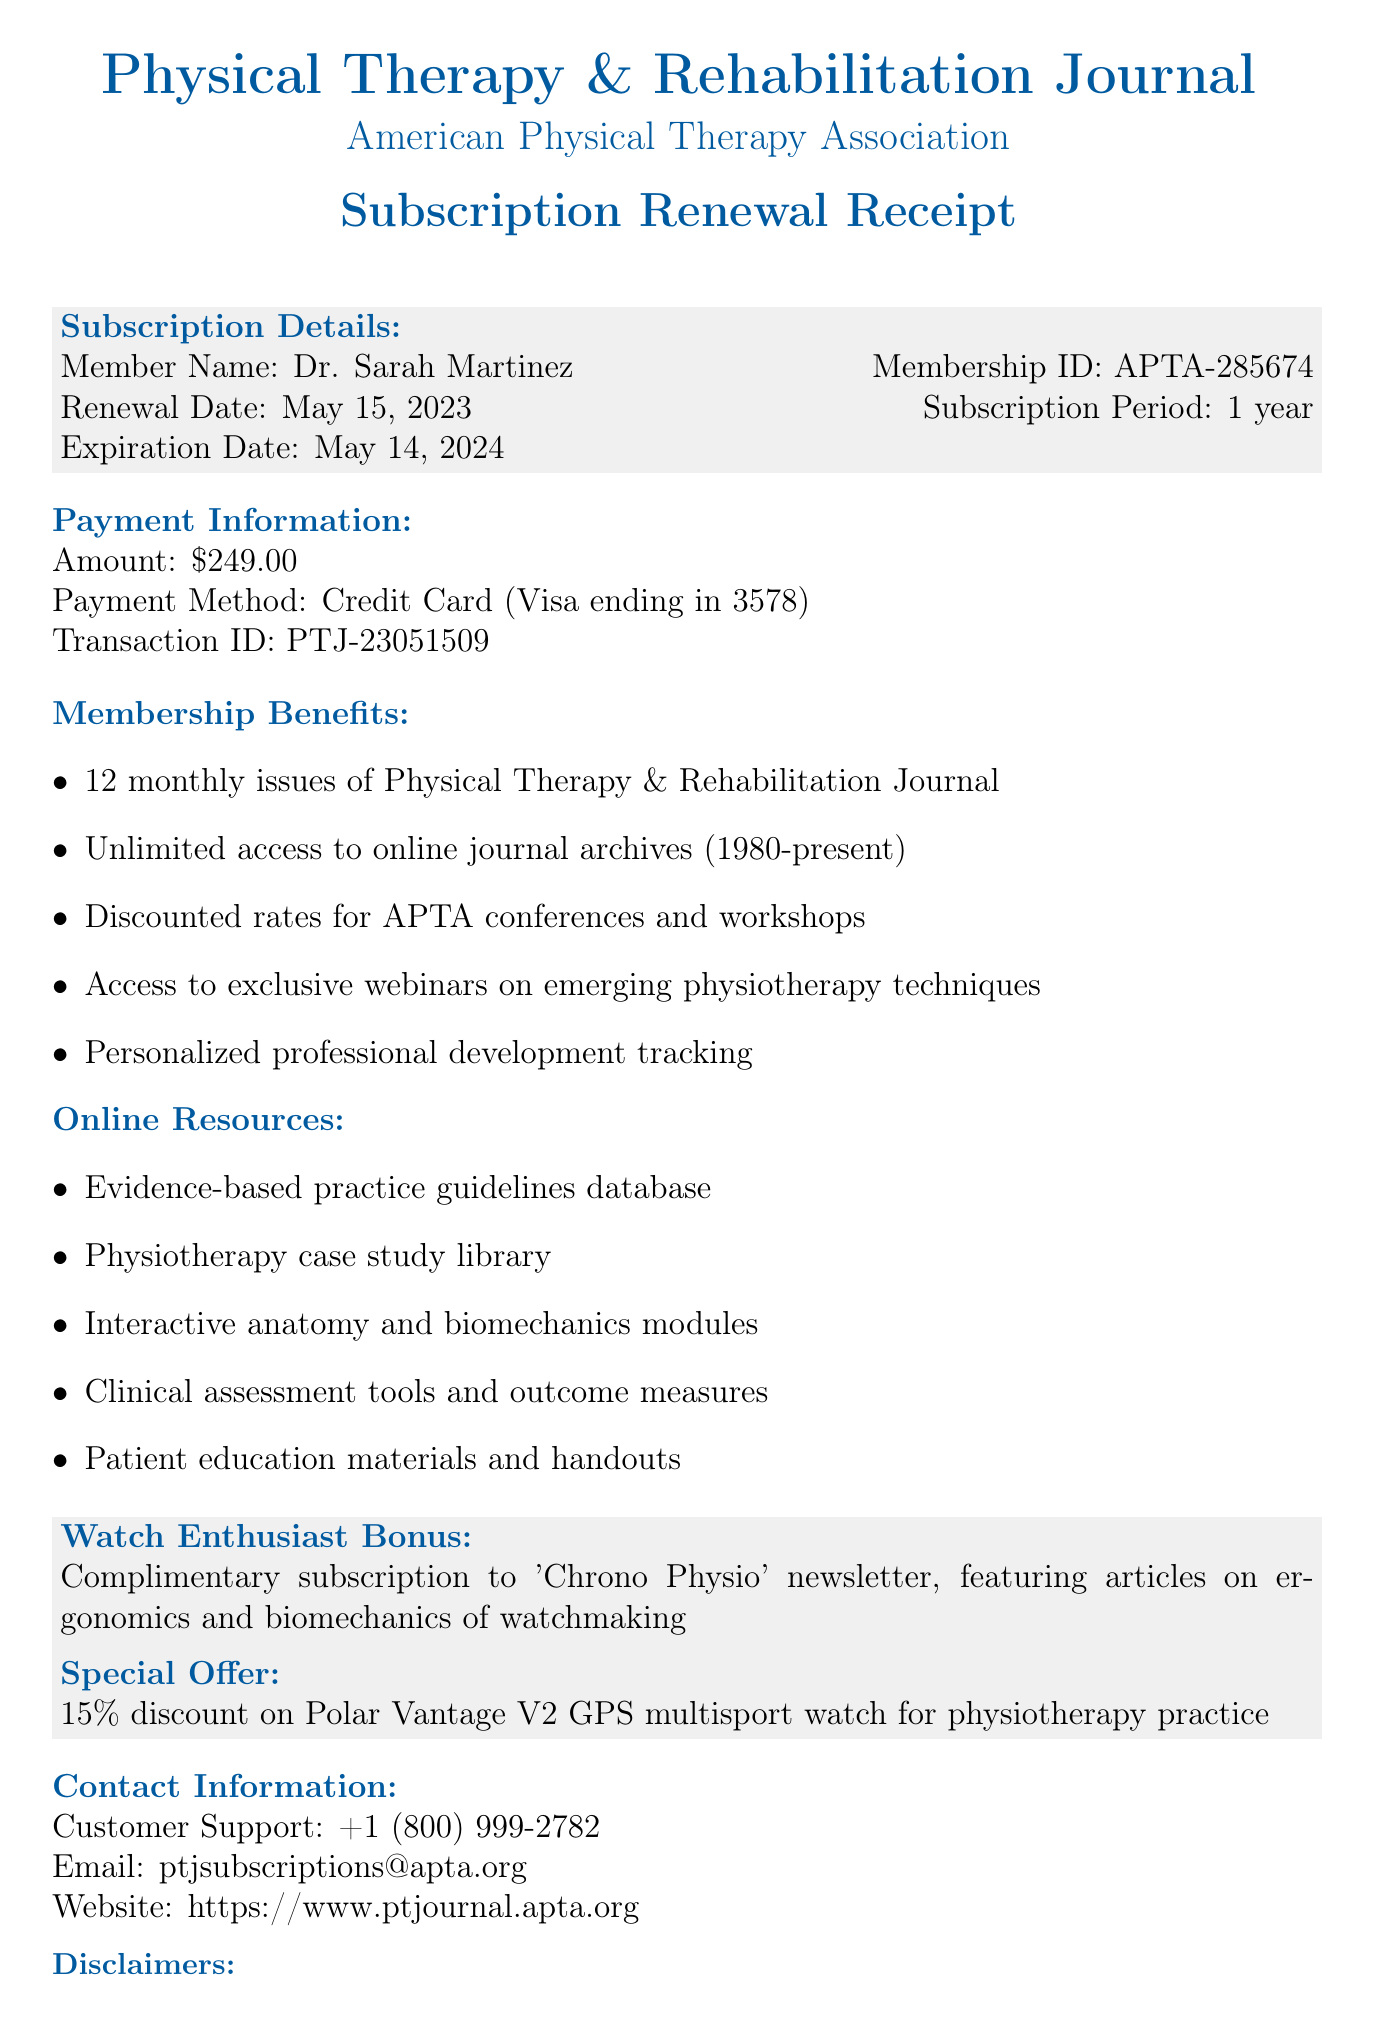What is the journal name? The journal name is provided at the top of the document as the title for the subscription renewal receipt.
Answer: Physical Therapy & Rehabilitation Journal Who is the member listed in the subscription details? The member's name is explicitly mentioned in the subscription details section of the document.
Answer: Dr. Sarah Martinez What is the renewal date? The renewal date is stated in the subscription details, indicating when the subscription was renewed.
Answer: May 15, 2023 How long is the subscription period? The subscription period is specified in the subscription details, indicating the duration of the subscription.
Answer: 1 year What payment method was used for the transaction? The payment method is described in the payment information section of the document.
Answer: Credit Card (Visa ending in 3578) How many monthly issues are included in the membership benefits? The number of monthly issues is listed specifically as part of the membership benefits in the document.
Answer: 12 What type of discount is offered for the Polar Vantage V2 watch? The discount type is detailed in the additional perks section related to the watch enthusiast bonus.
Answer: 15% discount What is the contact email for customer support? The contact email is provided in the contact information section for reaching out for any inquiries.
Answer: ptjsubscriptions@apta.org What is a disclaimer mentioned in the document? The disclaimers provided at the end discuss specific conditions regarding the subscription.
Answer: Subscription fees are non-refundable What additional resource can members access related to physiotherapy? The online resources section provides various resources available to members.
Answer: Evidence-based practice guidelines database 